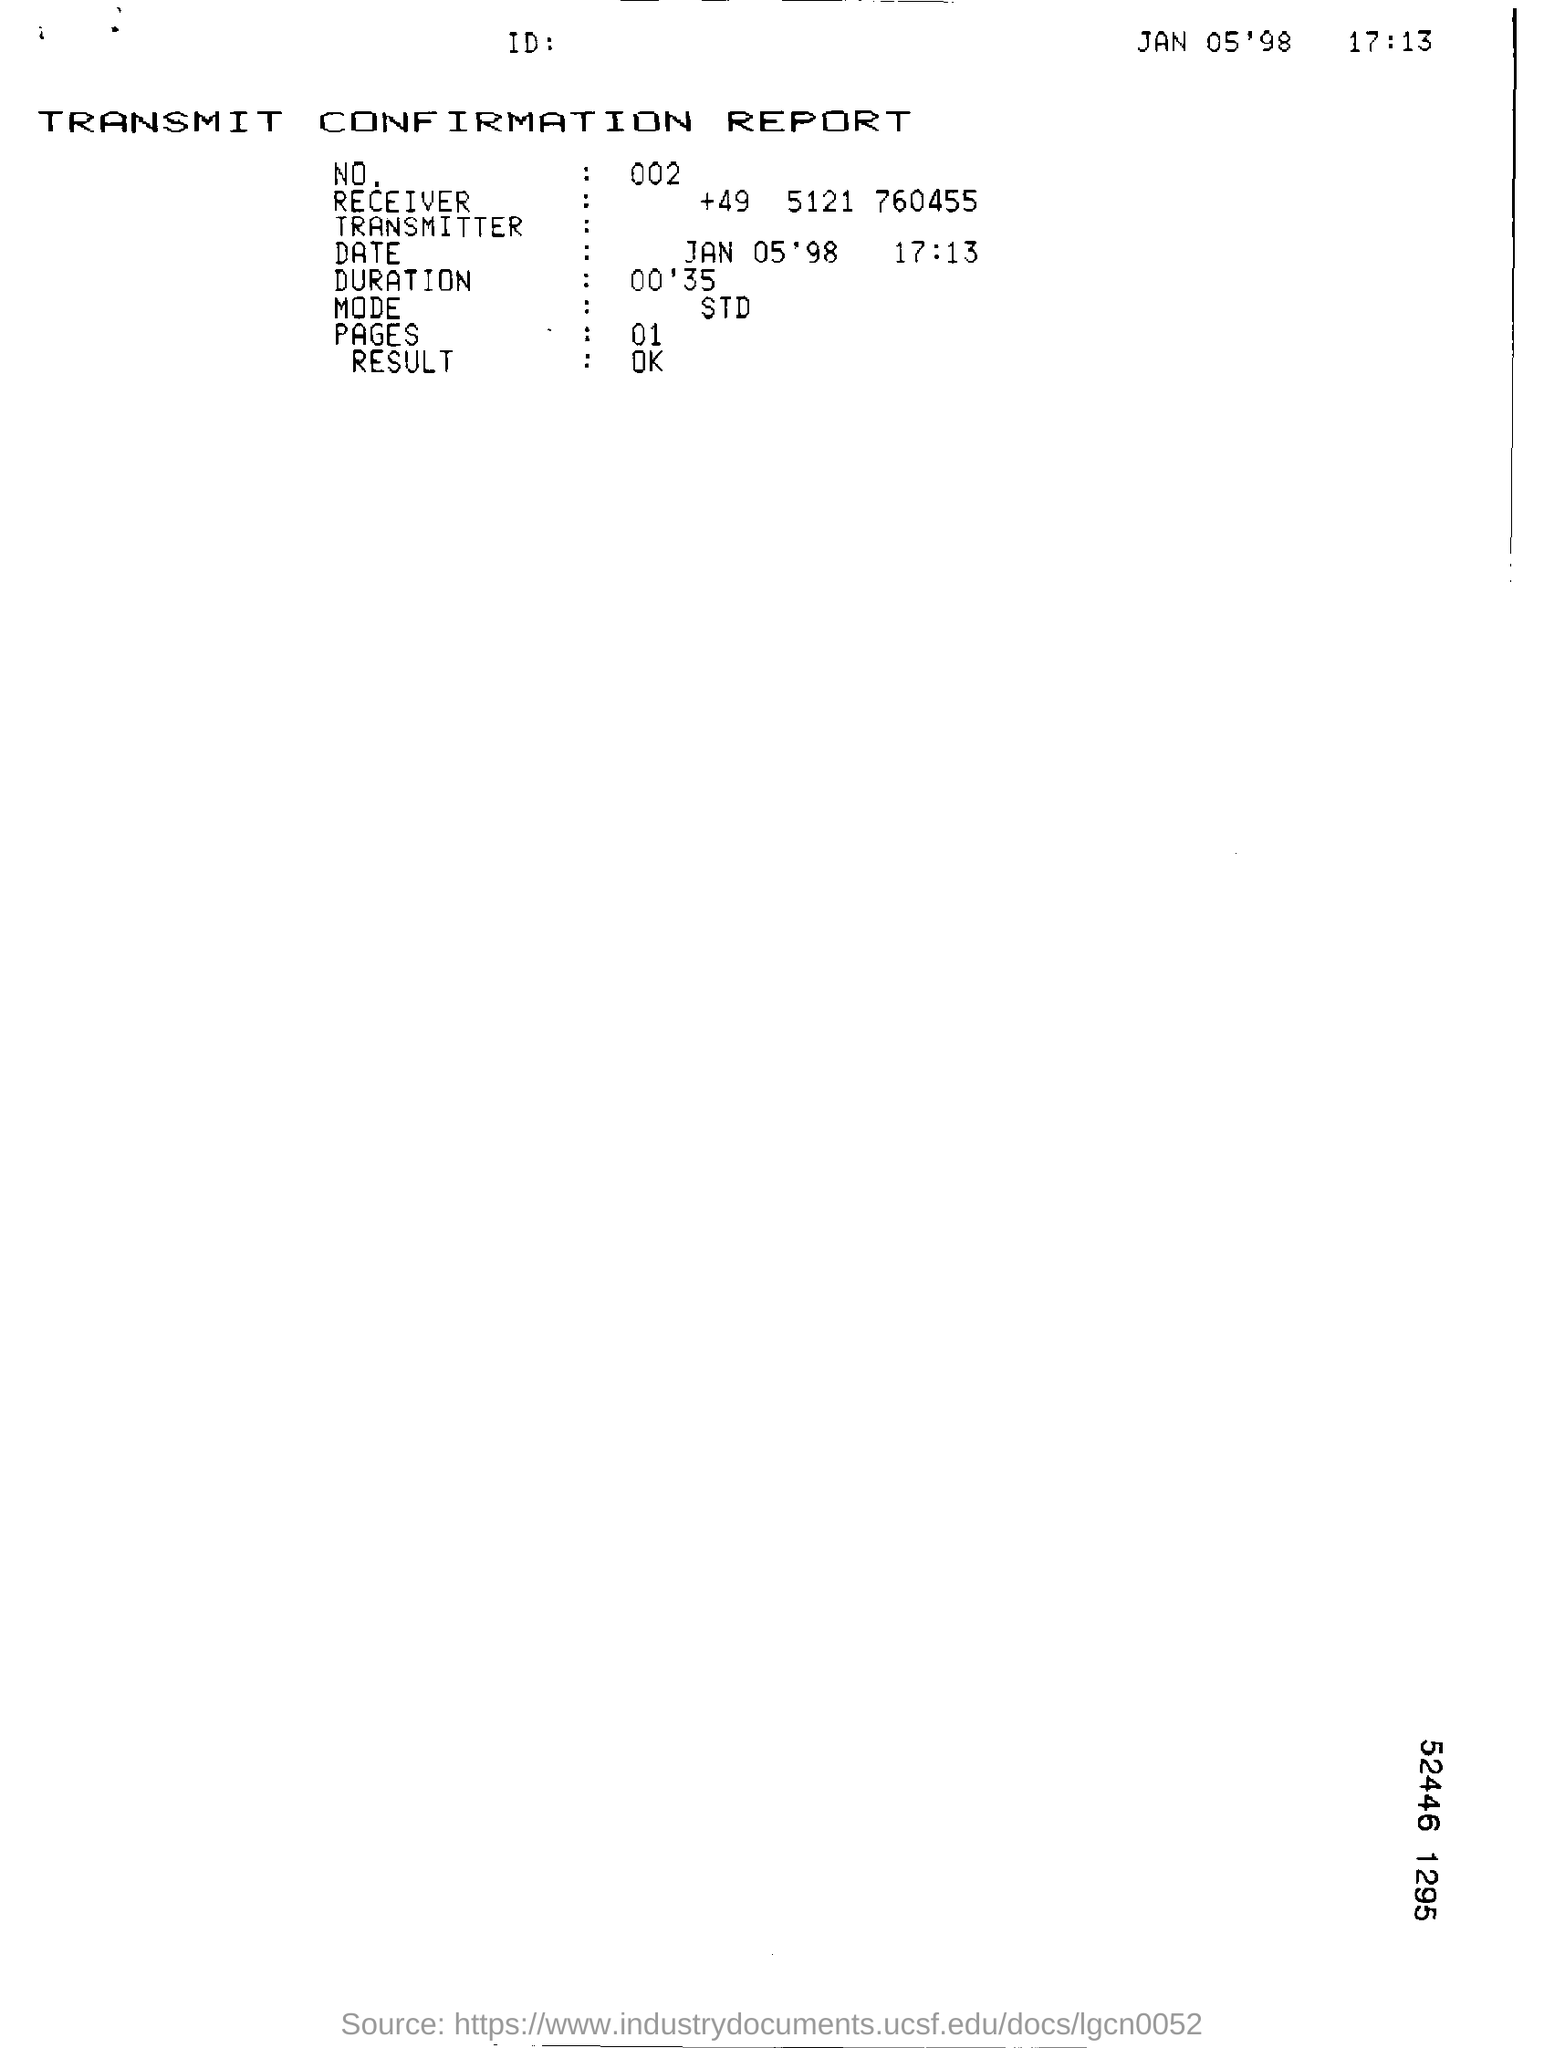What is the Date & time mentioned in the transmit confirmation report?
Offer a very short reply. JAN 05'98  17:13. What is the no. mentioned in the transmit confirmation report?
Provide a short and direct response. 002. What is the duration given in the transmit confirmation report?
Ensure brevity in your answer.  00'35. 